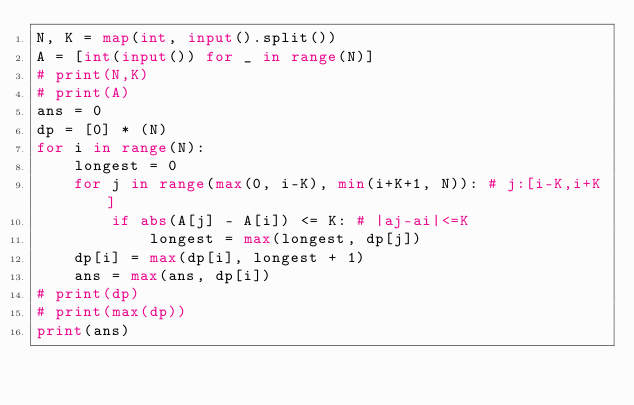<code> <loc_0><loc_0><loc_500><loc_500><_Python_>N, K = map(int, input().split())
A = [int(input()) for _ in range(N)]
# print(N,K)
# print(A)
ans = 0
dp = [0] * (N)
for i in range(N):
    longest = 0
    for j in range(max(0, i-K), min(i+K+1, N)): # j:[i-K,i+K]
        if abs(A[j] - A[i]) <= K: # |aj-ai|<=K
            longest = max(longest, dp[j])
    dp[i] = max(dp[i], longest + 1)
    ans = max(ans, dp[i])
# print(dp)
# print(max(dp))
print(ans)
</code> 